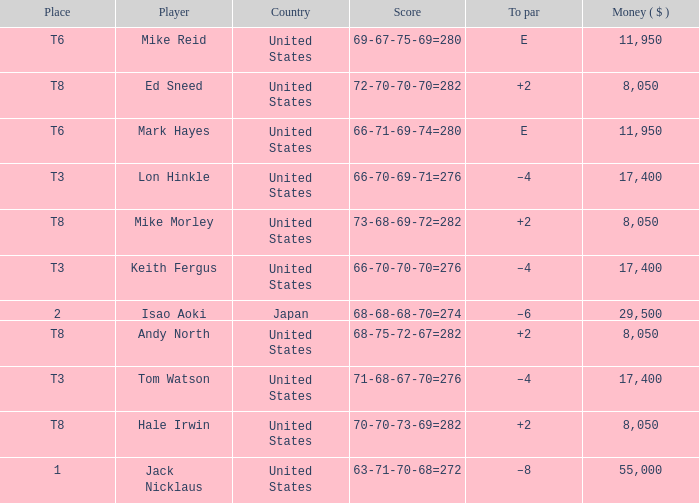What player has money larger than 11,950 and is placed in t8 and has the score of 73-68-69-72=282? None. 